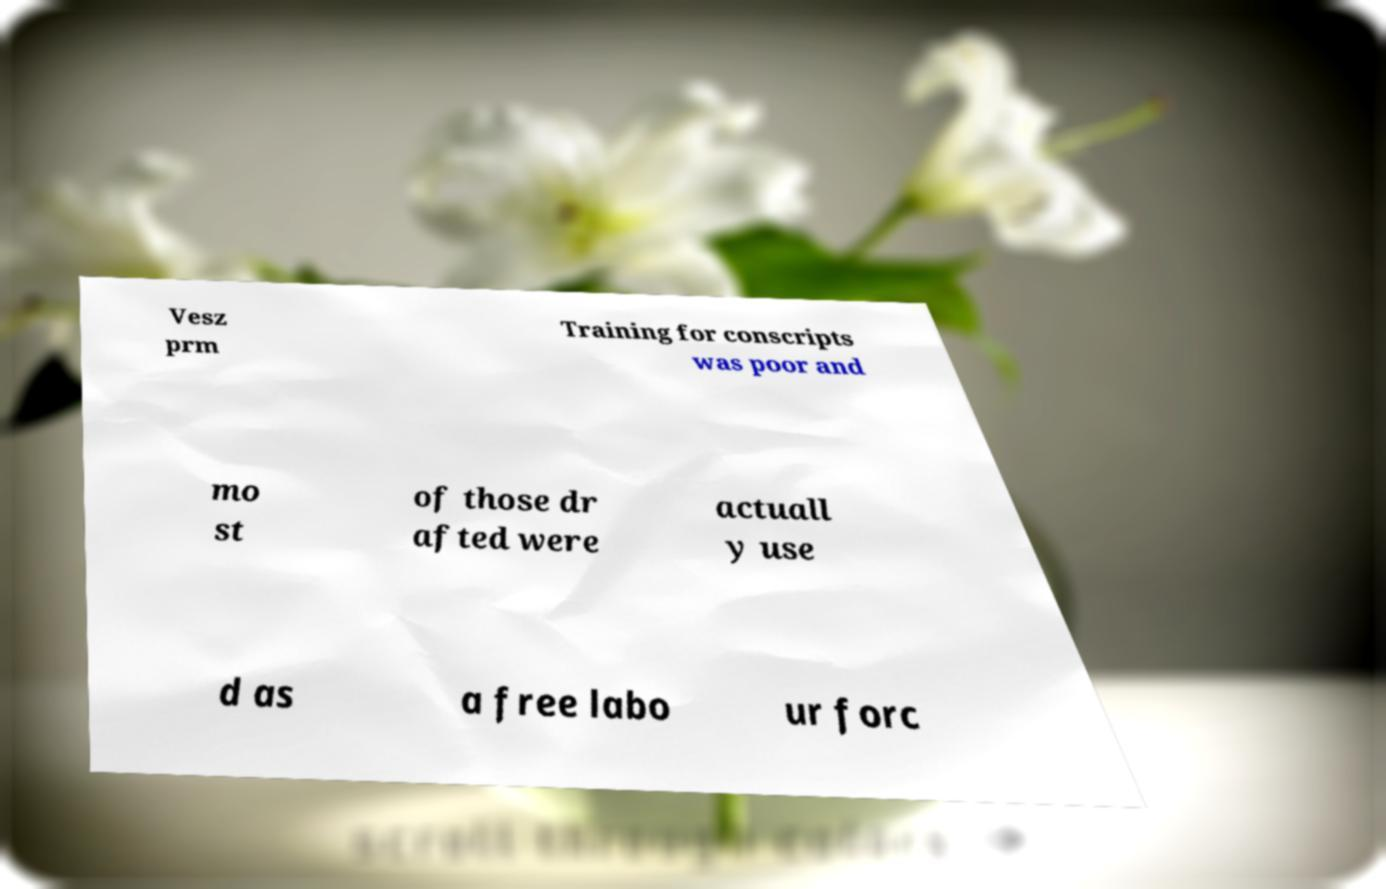For documentation purposes, I need the text within this image transcribed. Could you provide that? Vesz prm Training for conscripts was poor and mo st of those dr afted were actuall y use d as a free labo ur forc 